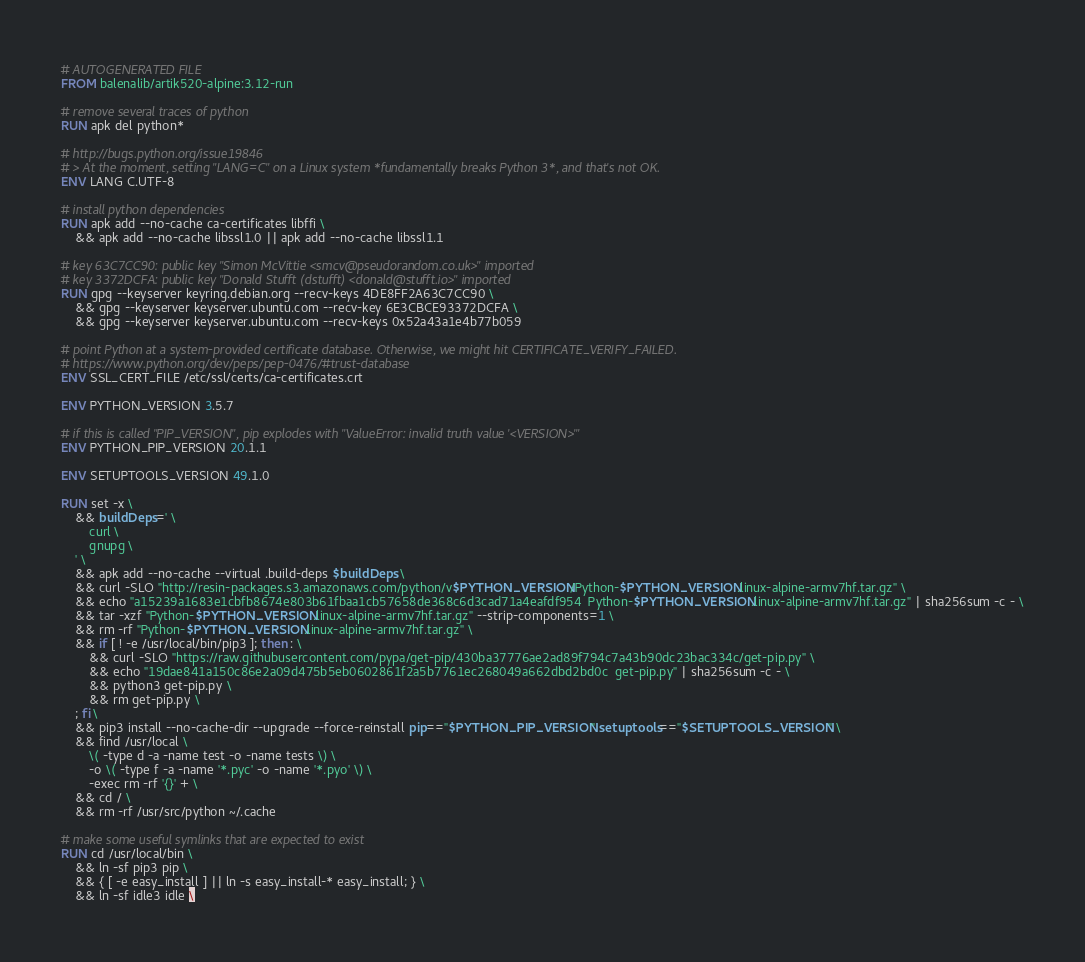<code> <loc_0><loc_0><loc_500><loc_500><_Dockerfile_># AUTOGENERATED FILE
FROM balenalib/artik520-alpine:3.12-run

# remove several traces of python
RUN apk del python*

# http://bugs.python.org/issue19846
# > At the moment, setting "LANG=C" on a Linux system *fundamentally breaks Python 3*, and that's not OK.
ENV LANG C.UTF-8

# install python dependencies
RUN apk add --no-cache ca-certificates libffi \
	&& apk add --no-cache libssl1.0 || apk add --no-cache libssl1.1

# key 63C7CC90: public key "Simon McVittie <smcv@pseudorandom.co.uk>" imported
# key 3372DCFA: public key "Donald Stufft (dstufft) <donald@stufft.io>" imported
RUN gpg --keyserver keyring.debian.org --recv-keys 4DE8FF2A63C7CC90 \
	&& gpg --keyserver keyserver.ubuntu.com --recv-key 6E3CBCE93372DCFA \
	&& gpg --keyserver keyserver.ubuntu.com --recv-keys 0x52a43a1e4b77b059

# point Python at a system-provided certificate database. Otherwise, we might hit CERTIFICATE_VERIFY_FAILED.
# https://www.python.org/dev/peps/pep-0476/#trust-database
ENV SSL_CERT_FILE /etc/ssl/certs/ca-certificates.crt

ENV PYTHON_VERSION 3.5.7

# if this is called "PIP_VERSION", pip explodes with "ValueError: invalid truth value '<VERSION>'"
ENV PYTHON_PIP_VERSION 20.1.1

ENV SETUPTOOLS_VERSION 49.1.0

RUN set -x \
	&& buildDeps=' \
		curl \
		gnupg \
	' \
	&& apk add --no-cache --virtual .build-deps $buildDeps \
	&& curl -SLO "http://resin-packages.s3.amazonaws.com/python/v$PYTHON_VERSION/Python-$PYTHON_VERSION.linux-alpine-armv7hf.tar.gz" \
	&& echo "a15239a1683e1cbfb8674e803b61fbaa1cb57658de368c6d3cad71a4eafdf954  Python-$PYTHON_VERSION.linux-alpine-armv7hf.tar.gz" | sha256sum -c - \
	&& tar -xzf "Python-$PYTHON_VERSION.linux-alpine-armv7hf.tar.gz" --strip-components=1 \
	&& rm -rf "Python-$PYTHON_VERSION.linux-alpine-armv7hf.tar.gz" \
	&& if [ ! -e /usr/local/bin/pip3 ]; then : \
		&& curl -SLO "https://raw.githubusercontent.com/pypa/get-pip/430ba37776ae2ad89f794c7a43b90dc23bac334c/get-pip.py" \
		&& echo "19dae841a150c86e2a09d475b5eb0602861f2a5b7761ec268049a662dbd2bd0c  get-pip.py" | sha256sum -c - \
		&& python3 get-pip.py \
		&& rm get-pip.py \
	; fi \
	&& pip3 install --no-cache-dir --upgrade --force-reinstall pip=="$PYTHON_PIP_VERSION" setuptools=="$SETUPTOOLS_VERSION" \
	&& find /usr/local \
		\( -type d -a -name test -o -name tests \) \
		-o \( -type f -a -name '*.pyc' -o -name '*.pyo' \) \
		-exec rm -rf '{}' + \
	&& cd / \
	&& rm -rf /usr/src/python ~/.cache

# make some useful symlinks that are expected to exist
RUN cd /usr/local/bin \
	&& ln -sf pip3 pip \
	&& { [ -e easy_install ] || ln -s easy_install-* easy_install; } \
	&& ln -sf idle3 idle \</code> 